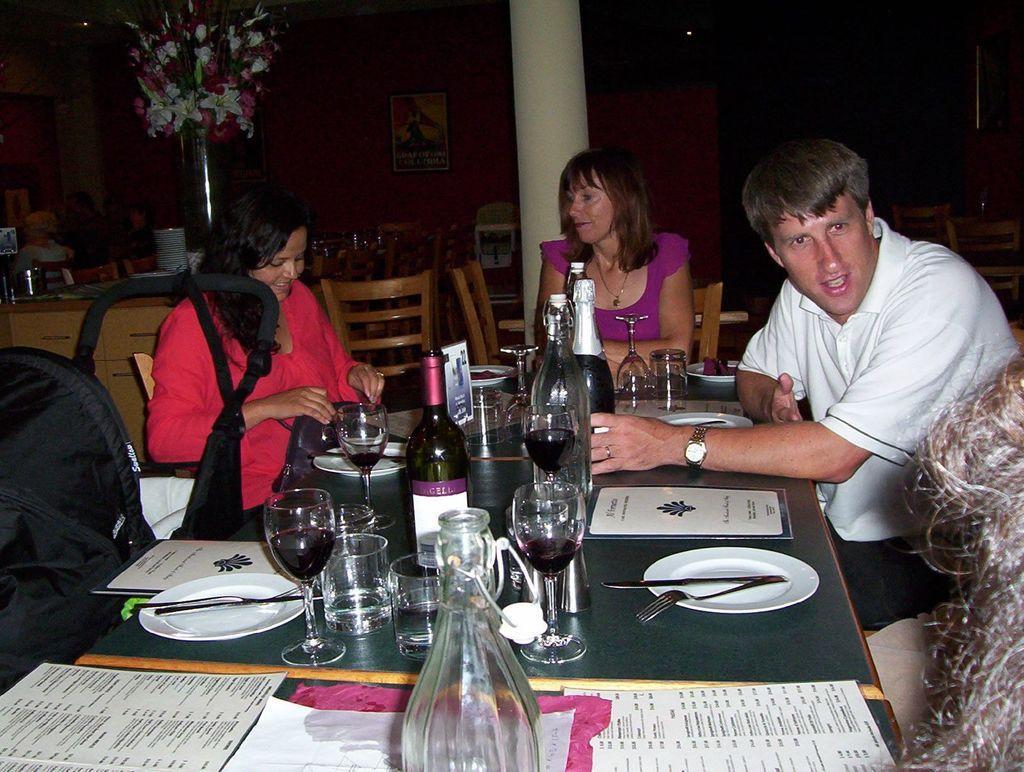Describe this image in one or two sentences. In the middle there is a table on the table there are many plates ,glasses , bottles ,papers and some other food items. On the right there is a man he wear white t shirt ,trouser and watch. In the middle there is a woman she wear pink dress her hair is short. On the left there is a woman she wear red dress her hair is short. In the back ground there are many tables and chairs and one flower vase and pillar. 